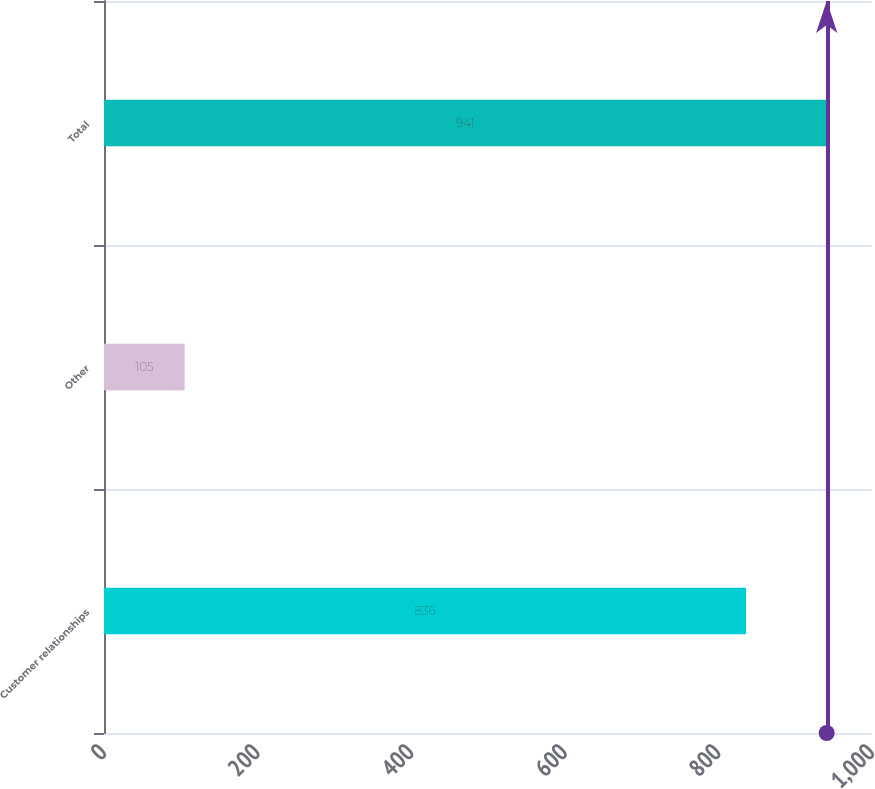Convert chart to OTSL. <chart><loc_0><loc_0><loc_500><loc_500><bar_chart><fcel>Customer relationships<fcel>Other<fcel>Total<nl><fcel>836<fcel>105<fcel>941<nl></chart> 